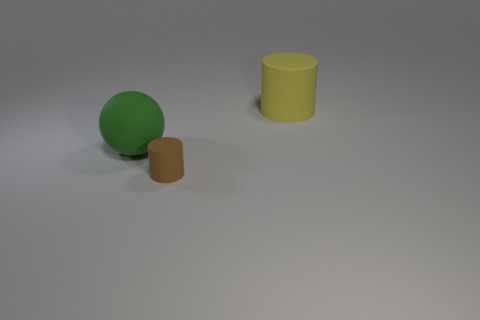How many other objects are there of the same size as the rubber sphere?
Keep it short and to the point. 1. What is the shape of the big yellow thing that is the same material as the green sphere?
Provide a succinct answer. Cylinder. Are there the same number of small brown cylinders that are in front of the yellow cylinder and large green matte things behind the green ball?
Keep it short and to the point. No. There is a green object; is its size the same as the matte cylinder on the right side of the brown cylinder?
Your answer should be compact. Yes. Are there more tiny brown cylinders that are in front of the big green matte thing than big red matte cylinders?
Your response must be concise. Yes. What number of balls are the same size as the yellow rubber thing?
Provide a short and direct response. 1. Does the rubber thing behind the green matte sphere have the same size as the object on the left side of the small brown rubber cylinder?
Your answer should be compact. Yes. Is the number of yellow rubber objects behind the small thing greater than the number of large yellow matte things that are in front of the green sphere?
Offer a terse response. Yes. How many other tiny rubber things are the same shape as the tiny thing?
Your answer should be very brief. 0. What is the material of the thing that is the same size as the rubber sphere?
Your answer should be compact. Rubber. 